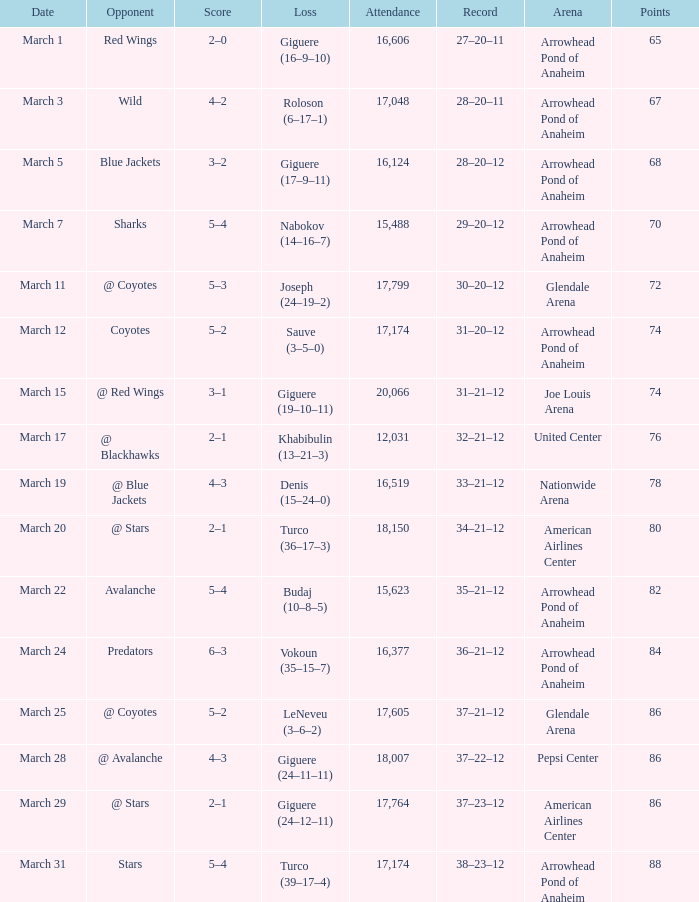What is the number of attendees at joe louis arena? 20066.0. 